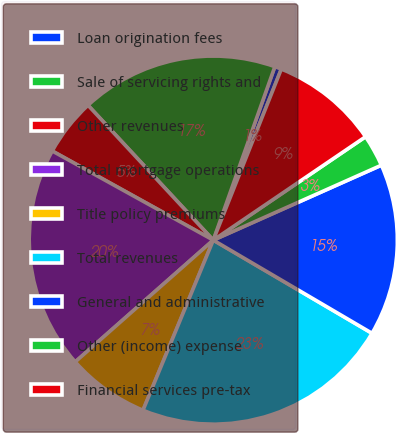Convert chart. <chart><loc_0><loc_0><loc_500><loc_500><pie_chart><fcel>Loan origination fees<fcel>Sale of servicing rights and<fcel>Other revenues<fcel>Total mortgage operations<fcel>Title policy premiums<fcel>Total revenues<fcel>General and administrative<fcel>Other (income) expense<fcel>Financial services pre-tax<nl><fcel>0.6%<fcel>17.34%<fcel>5.04%<fcel>19.55%<fcel>7.26%<fcel>22.79%<fcel>15.12%<fcel>2.82%<fcel>9.48%<nl></chart> 